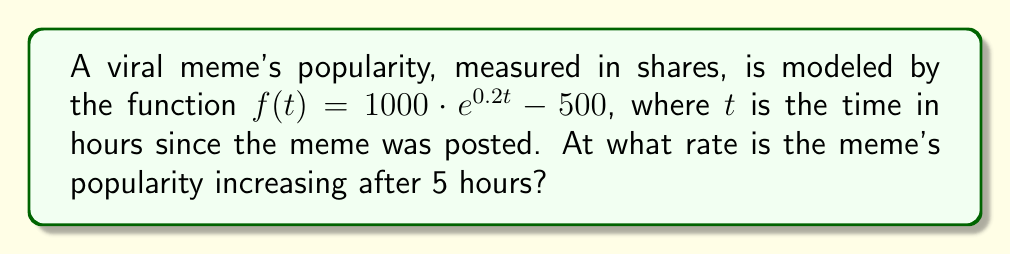Can you solve this math problem? To find the instantaneous growth rate of the meme's popularity after 5 hours, we need to calculate the derivative of the function $f(t)$ and evaluate it at $t=5$. 

Step 1: Find the derivative of $f(t)$
$$\frac{d}{dt}f(t) = \frac{d}{dt}(1000 \cdot e^{0.2t} - 500)$$
$$f'(t) = 1000 \cdot 0.2 \cdot e^{0.2t}$$
$$f'(t) = 200 \cdot e^{0.2t}$$

Step 2: Evaluate $f'(t)$ at $t=5$
$$f'(5) = 200 \cdot e^{0.2 \cdot 5}$$
$$f'(5) = 200 \cdot e^1$$
$$f'(5) = 200 \cdot 2.71828...$$
$$f'(5) \approx 543.66$$

The rate is measured in shares per hour, so we round to the nearest whole number.
Answer: 544 shares/hour 